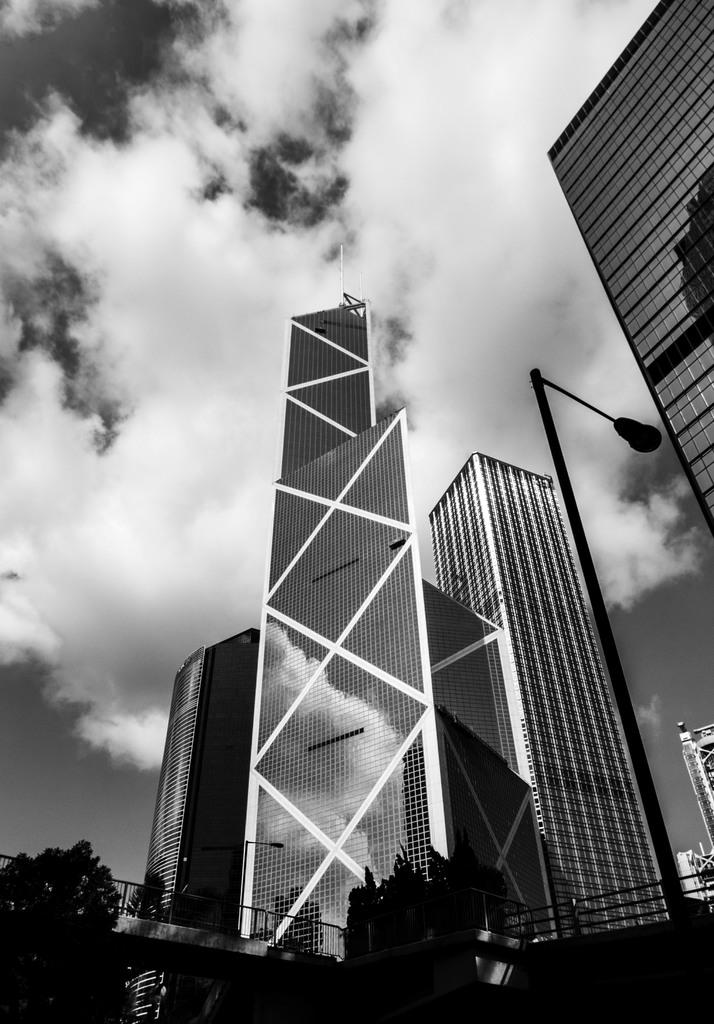What type of vegetation can be seen in the image? There are trees in the image. What structures are present in the image? There are poles and buildings in the image. What is visible in the background of the image? The sky is visible in the background of the image. What can be seen in the sky? Clouds are present in the sky. How many pages are visible in the image? There are no pages present in the image. What type of bubble can be seen in the image? There are no bubbles present in the image. 